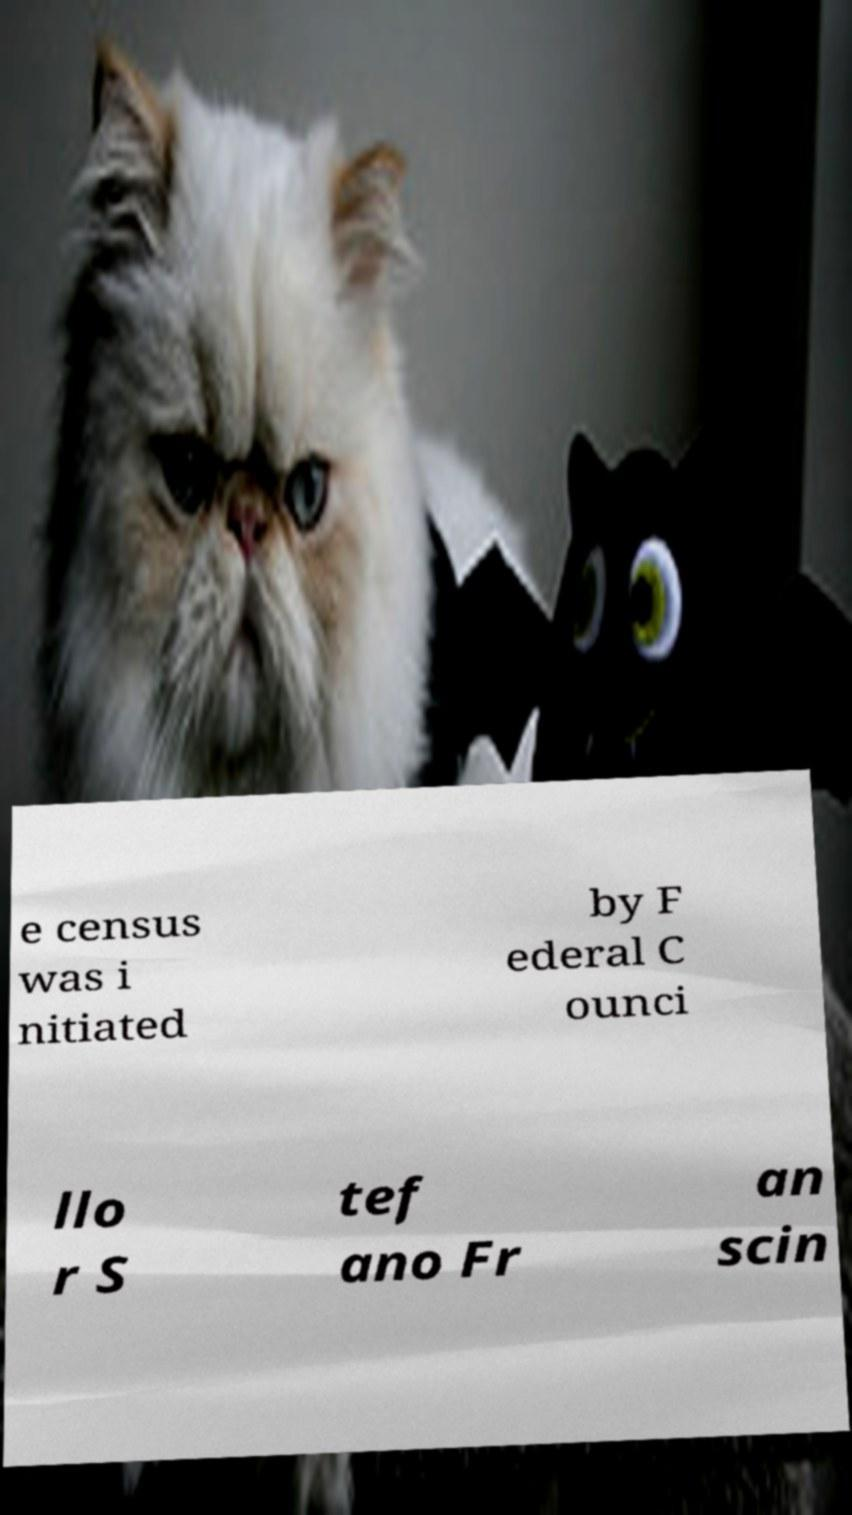There's text embedded in this image that I need extracted. Can you transcribe it verbatim? e census was i nitiated by F ederal C ounci llo r S tef ano Fr an scin 